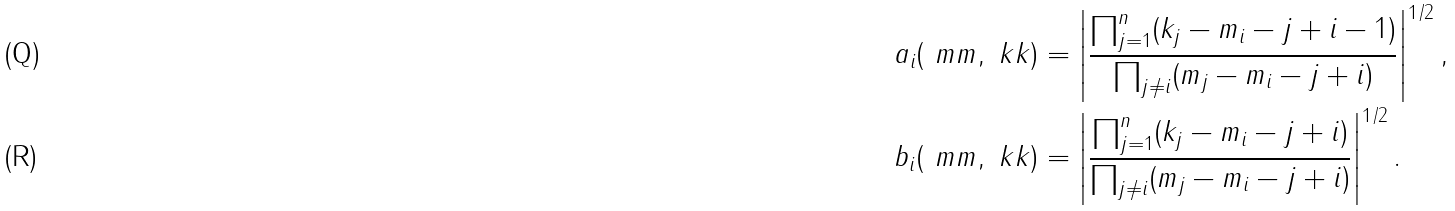Convert formula to latex. <formula><loc_0><loc_0><loc_500><loc_500>a _ { i } ( \ m m , \ k k ) & = \left | \frac { \prod _ { j = 1 } ^ { n } ( k _ { j } - m _ { i } - j + i - 1 ) } { \prod _ { j \ne i } ( m _ { j } - m _ { i } - j + i ) } \right | ^ { 1 / 2 } , \\ b _ { i } ( \ m m , \ k k ) & = \left | \frac { \prod _ { j = 1 } ^ { n } ( k _ { j } - m _ { i } - j + i ) } { \prod _ { j \ne i } ( m _ { j } - m _ { i } - j + i ) } \right | ^ { 1 / 2 } .</formula> 